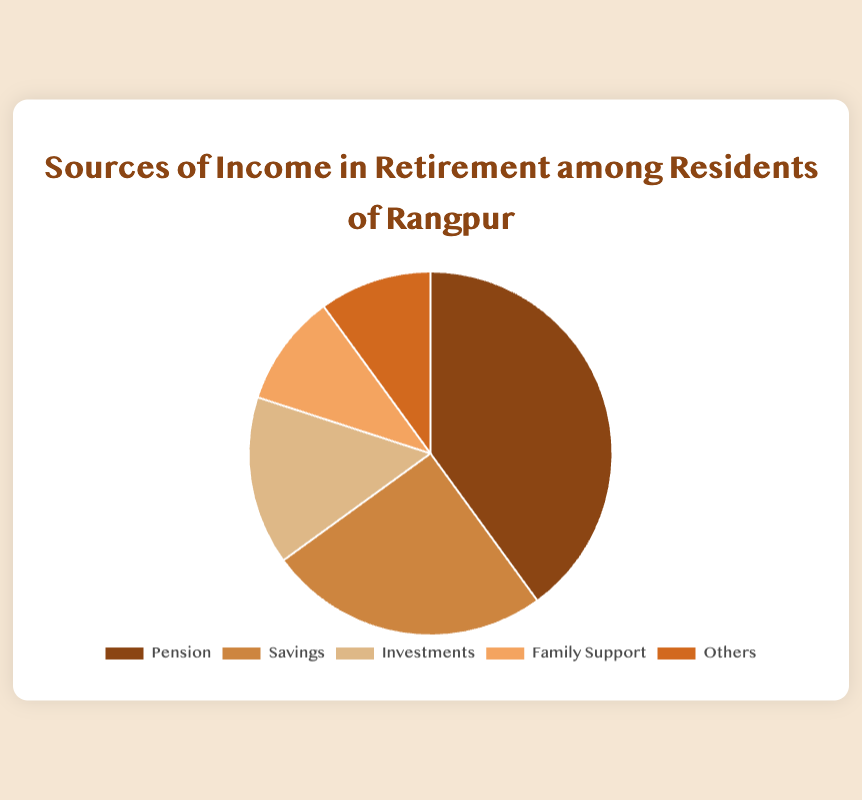Which source of income has the largest share? The figure shows that the source with the largest share is visually the biggest segment in the pie chart. The category labeled 'Pension' takes up 40% of the chart.
Answer: Pension What is the combined percentage of 'Investments' and 'Family Support'? To find the combined percentage, add the percentages of Investments (15%) and Family Support (10%). Thus, 15% + 10% = 25%.
Answer: 25% How does the contribution of 'Savings' compare to 'Others'? By observing the pie chart, Savings has a larger slice compared to Others. Savings is 25%, while Others is 10%.
Answer: Savings has a higher percentage than Others Which two sources have equal shares? The pie chart indicates that 'Family Support' and 'Others' both occupy the same slice size, consisting of 10% each.
Answer: Family Support and Others If Savings were to decrease by 5%, which two categories would then have the same percentage? Currently, Savings is 25%. If it decreases by 5%, it would become 20%. Investments and the adjusted Savings would both be 15%.
Answer: Savings and Investments What is the total percentage of non-pension sources of income? To find this, add the percentages of all sources except Pension (40%): Savings (25%) + Investments (15%) + Family Support (10%) + Others (10%). Thus, the total is 25% + 15% + 10% + 10% = 60%.
Answer: 60% Which source has the second-largest percentage, and by how much does it differ from the largest source? The second-largest percentage is Savings at 25%. It differs from Pension by 15% since Pension is 40%.
Answer: Savings, 15% How many income sources contribute to at least 15% each? In the pie chart, the categories of Pension (40%), Savings (25%), and Investments (15%) each contribute at least 15%.
Answer: 3 sources What percentage of income sources comes from either Family Support or Others? Adding Family Support (10%) with Others (10%), the sum is 10% + 10% = 20%.
Answer: 20% 